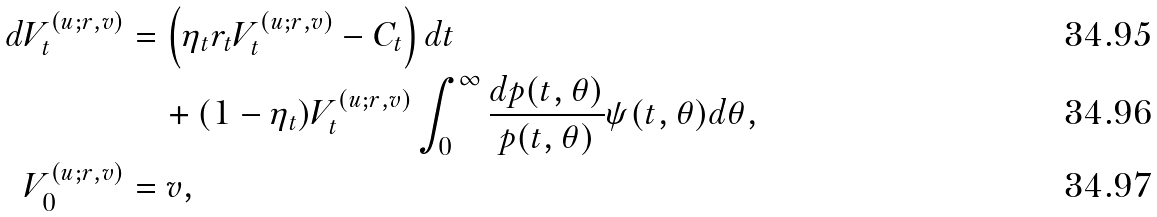<formula> <loc_0><loc_0><loc_500><loc_500>d V _ { t } ^ { ( u ; r , v ) } & = \left ( \eta _ { t } r _ { t } V _ { t } ^ { ( u ; r , v ) } - C _ { t } \right ) d t \\ & \quad + ( 1 - \eta _ { t } ) V _ { t } ^ { ( u ; r , v ) } \int _ { 0 } ^ { \infty } \frac { d p ( t , \theta ) } { p ( t , \theta ) } \psi ( t , \theta ) d \theta , \\ V _ { 0 } ^ { ( u ; r , v ) } & = v ,</formula> 